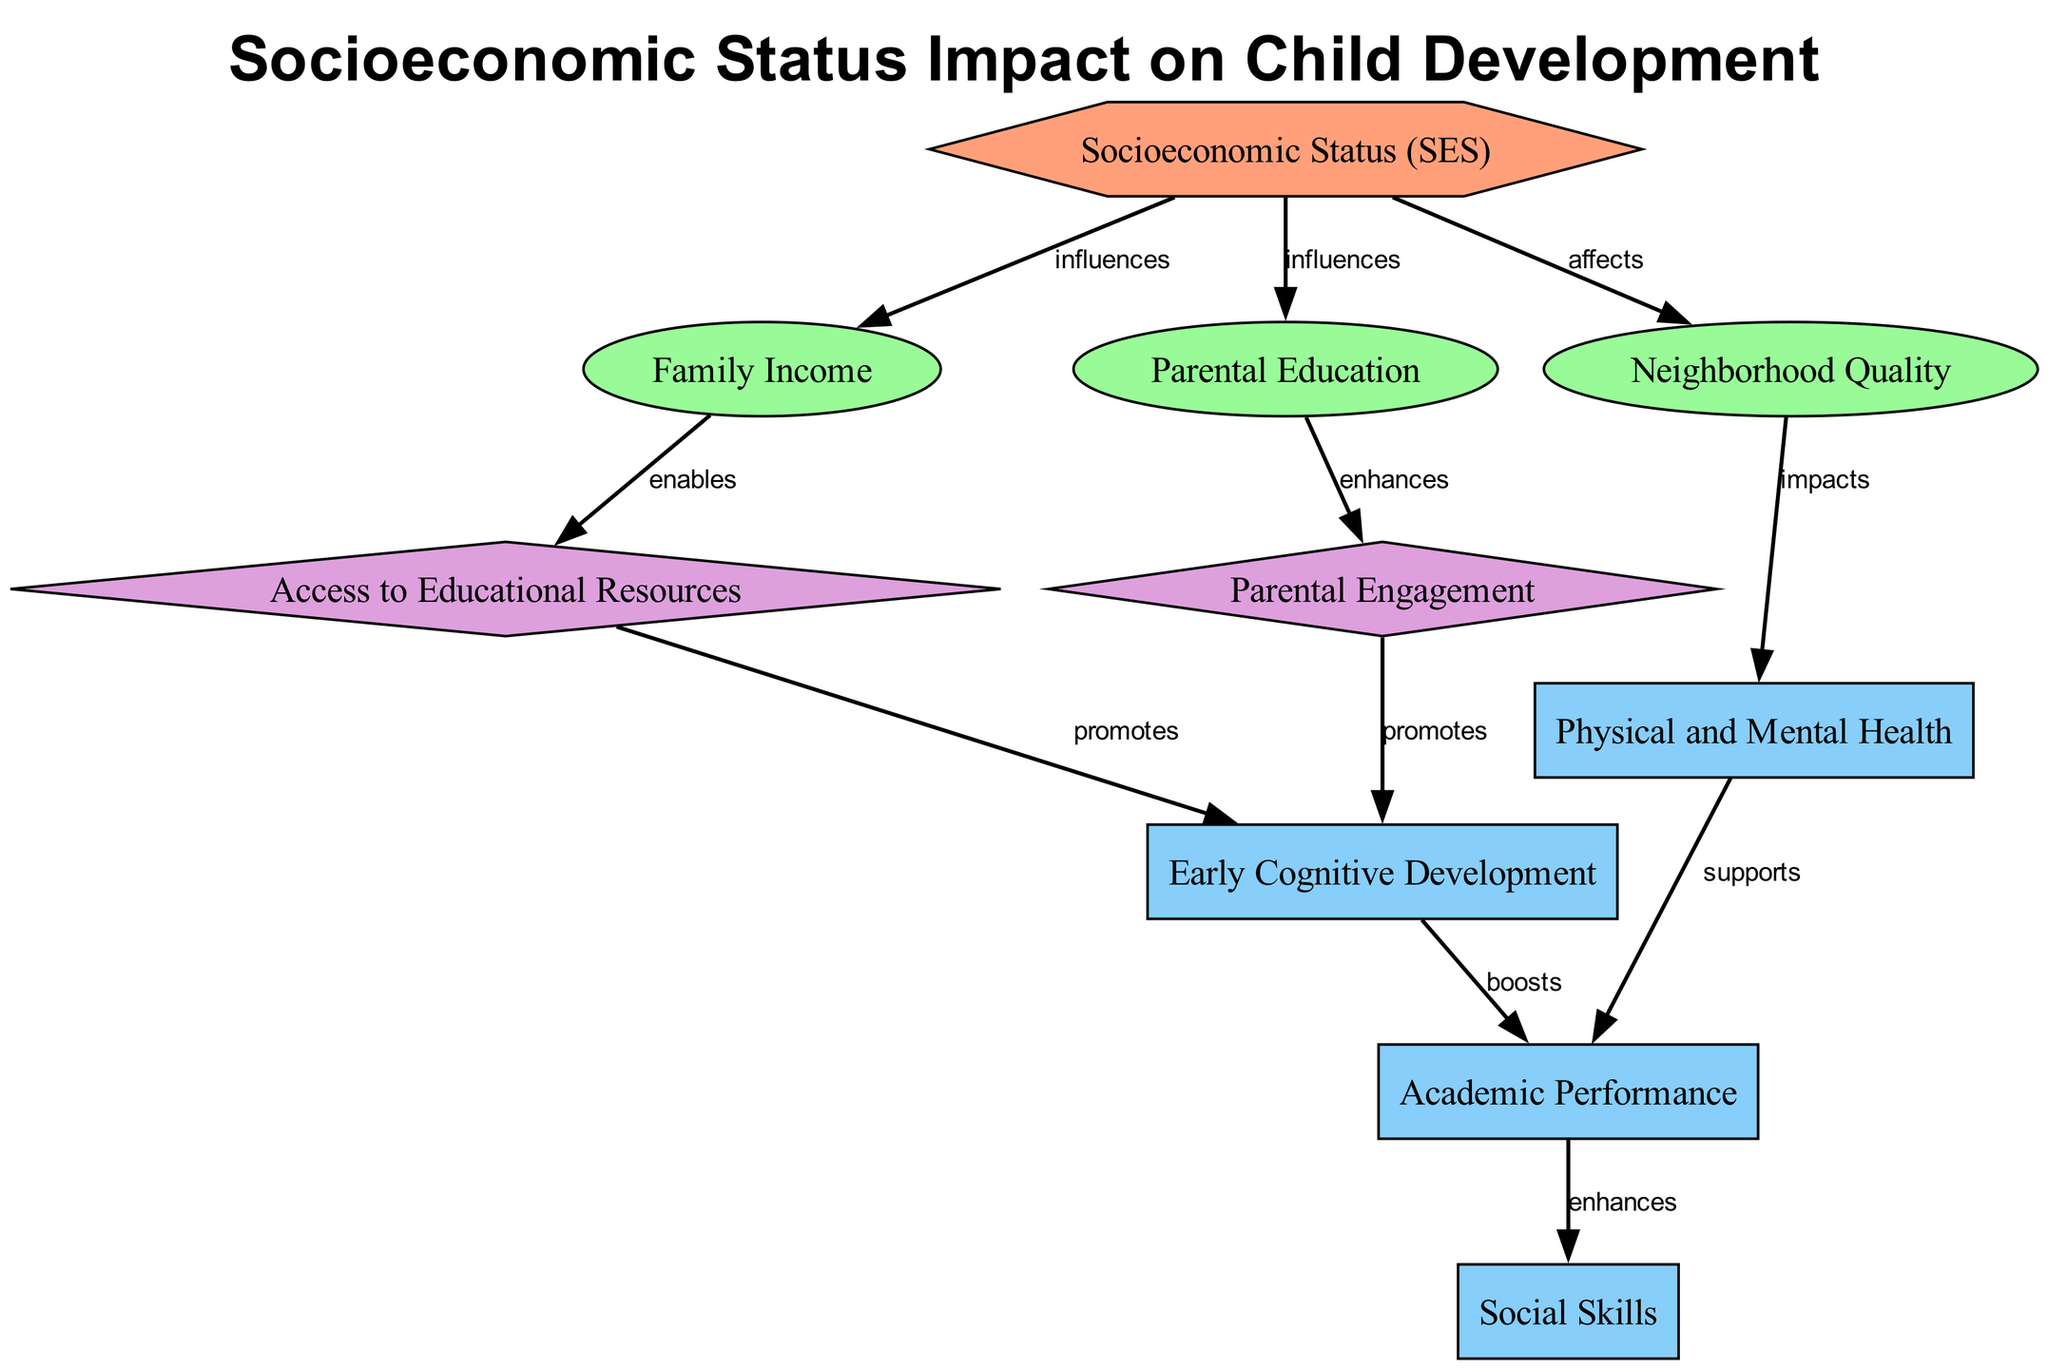What type of node is "SES"? The label "SES" is classified as a factor node in the diagram based on the "type" field provided for each node.
Answer: factor What does "income" directly influence? The diagram indicates that "income" directly influences "access to Educational Resources" as evidenced by the edge labeled "enables" connecting these two nodes.
Answer: access to Educational Resources How many outcome nodes are there in the diagram? By counting the nodes classified as "outcome" type, we identify four: "Early Cognitive Development," "Academic Performance," "Social Skills," and "Physical and Mental Health." Thus, there are a total of four outcome nodes.
Answer: 4 What is the relationship between "neighborhood" and "health"? The edge connecting "neighborhood" to "health" is labeled "impacts," which indicates that the quality of the neighborhood plays a role in affecting health outcomes.
Answer: impacts Which two variables enhance "parent_engage"? The diagram does not specify direct enhancement for "parent_engage" beyond the influence of "parent_ed," which enhances it; therefore, the only variable identified is "parent_ed."
Answer: parent_ed What node is boosted by "early_dev"? The diagram shows a directional edge from "early_dev" to "academic_perf," indicating that early cognitive development boosts academic performance.
Answer: academic_perf How does "SES" affect "academic_perf"? "SES" influences "academic_perf" indirectly through several nodes, specifically through its effects on "income," which enables "access to Educational Resources," and "early_dev," which boosts "academic_perf."
Answer: indirectly How many mediators are in the diagram? Counting the nodes labeled as "mediator," we find two: "Access to Educational Resources" and "Parental Engagement," giving a total of two mediator nodes in the diagram.
Answer: 2 What type of impact does "health" have on "academic_perf"? The relationship between "health" and "academic_perf" is labeled "supports," indicating that health status positively helps or supports academic performance.
Answer: supports 